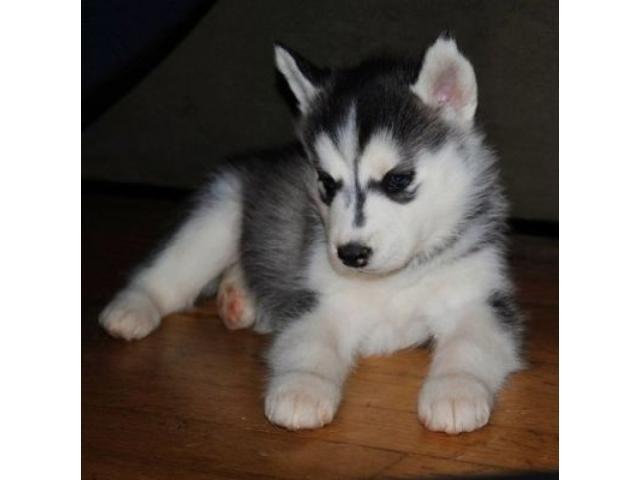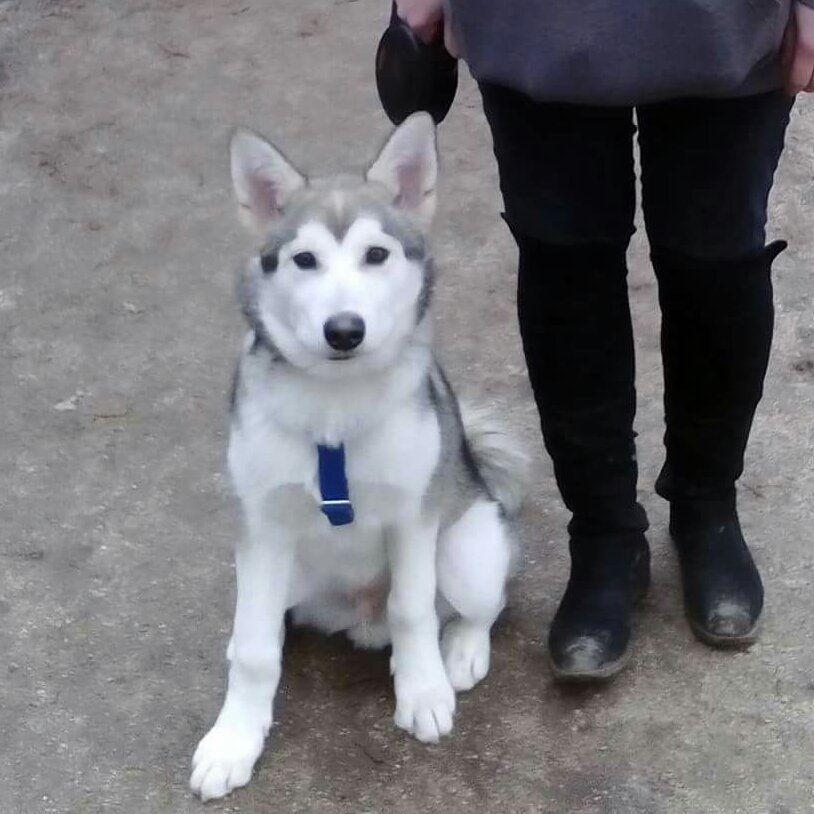The first image is the image on the left, the second image is the image on the right. Examine the images to the left and right. Is the description "The left and right image contains the same number of dogs." accurate? Answer yes or no. Yes. The first image is the image on the left, the second image is the image on the right. Given the left and right images, does the statement "There are exactly three dogs in total." hold true? Answer yes or no. No. 